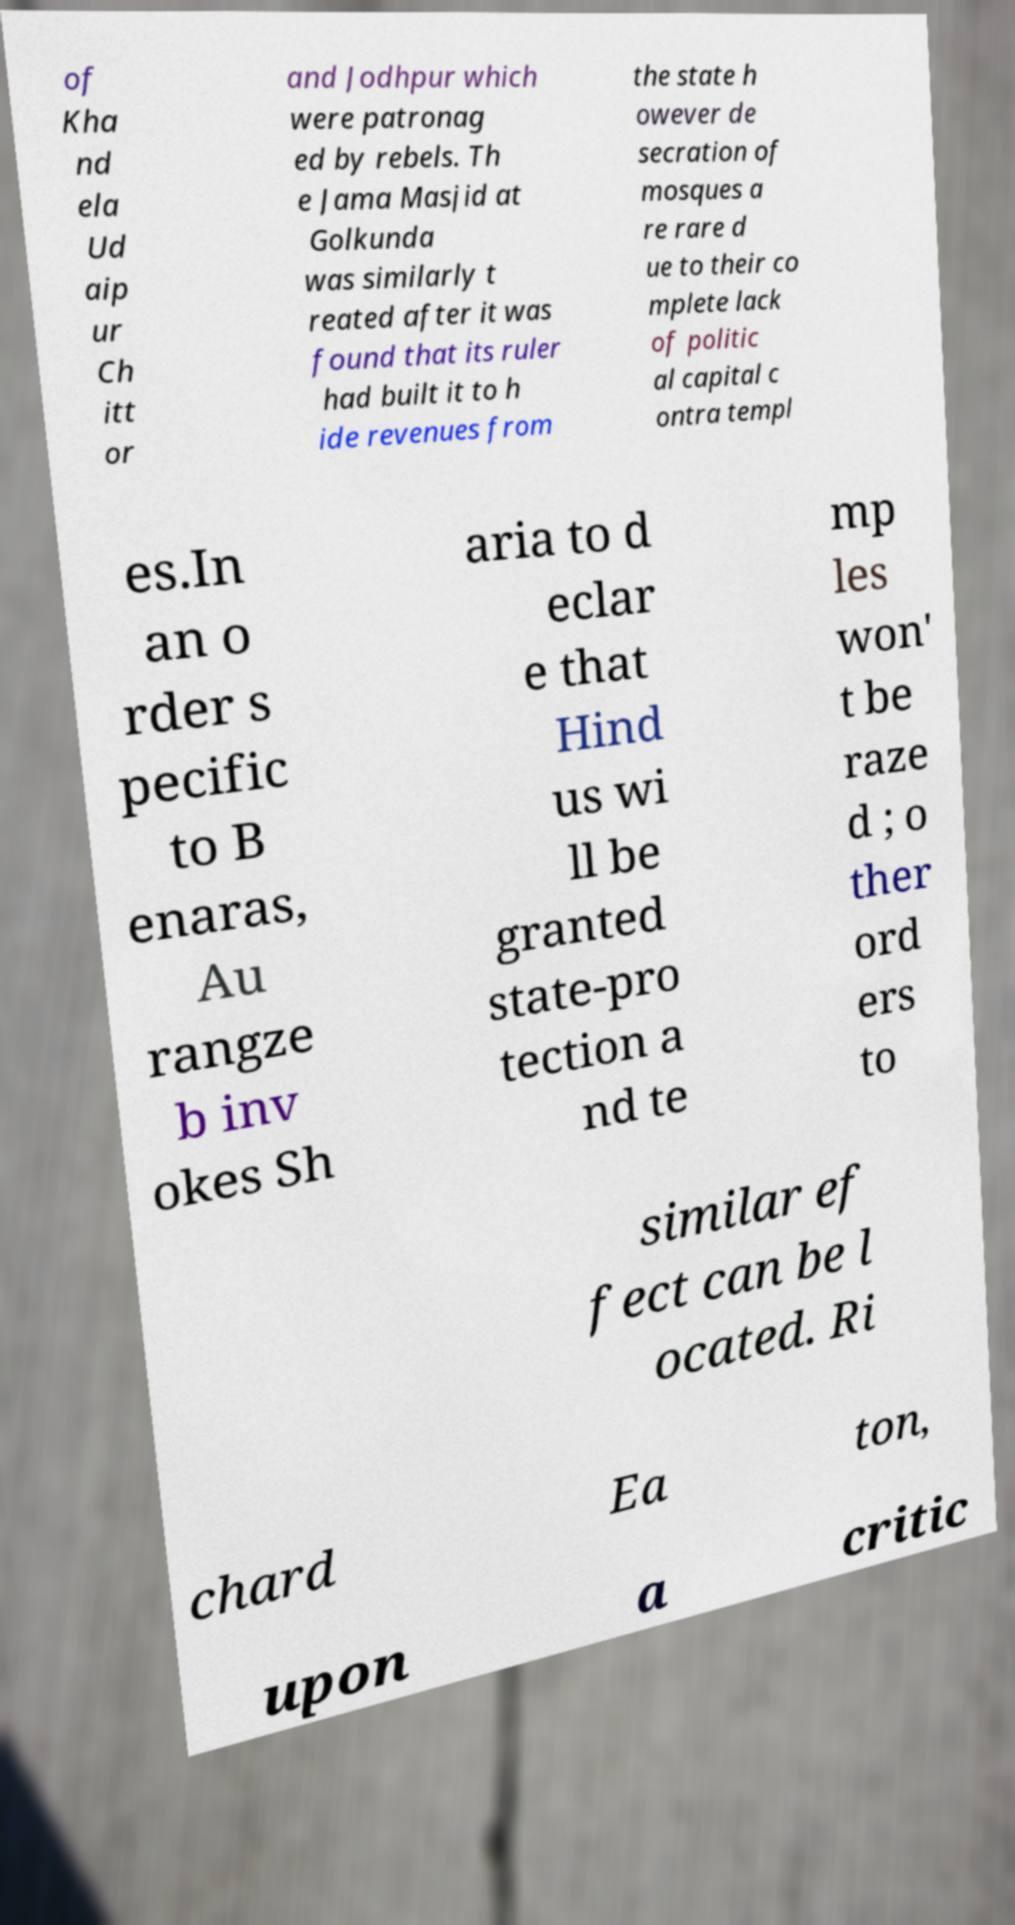Please read and relay the text visible in this image. What does it say? of Kha nd ela Ud aip ur Ch itt or and Jodhpur which were patronag ed by rebels. Th e Jama Masjid at Golkunda was similarly t reated after it was found that its ruler had built it to h ide revenues from the state h owever de secration of mosques a re rare d ue to their co mplete lack of politic al capital c ontra templ es.In an o rder s pecific to B enaras, Au rangze b inv okes Sh aria to d eclar e that Hind us wi ll be granted state-pro tection a nd te mp les won' t be raze d ; o ther ord ers to similar ef fect can be l ocated. Ri chard Ea ton, upon a critic 